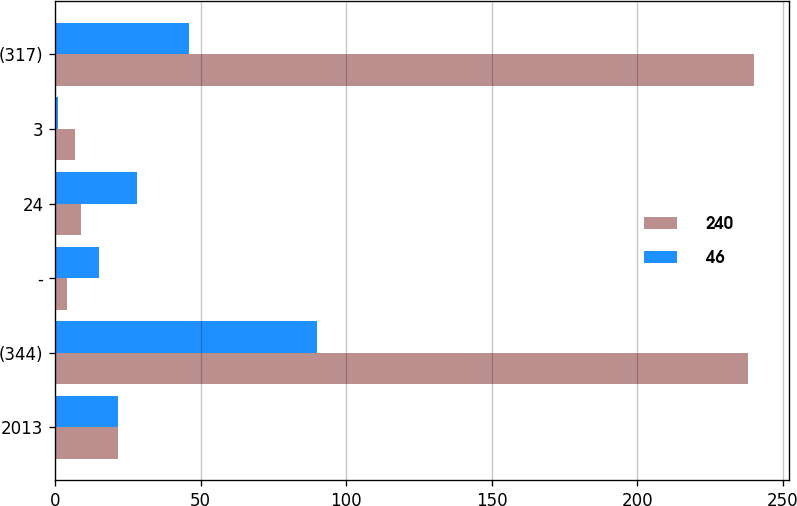Convert chart to OTSL. <chart><loc_0><loc_0><loc_500><loc_500><stacked_bar_chart><ecel><fcel>2013<fcel>(344)<fcel>-<fcel>24<fcel>3<fcel>(317)<nl><fcel>240<fcel>21.5<fcel>238<fcel>4<fcel>9<fcel>7<fcel>240<nl><fcel>46<fcel>21.5<fcel>90<fcel>15<fcel>28<fcel>1<fcel>46<nl></chart> 